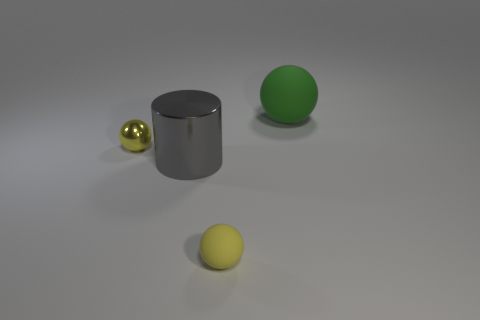Are there any other things that are the same material as the big gray object?
Give a very brief answer. Yes. What number of things are objects that are in front of the gray metallic thing or large objects?
Your response must be concise. 3. Is there a green matte sphere left of the big object in front of the big green rubber thing that is behind the cylinder?
Give a very brief answer. No. How many cyan cylinders are there?
Offer a terse response. 0. How many things are spheres on the right side of the large gray object or metallic objects behind the large gray object?
Offer a very short reply. 3. Is the size of the yellow sphere to the right of the gray object the same as the large green sphere?
Make the answer very short. No. There is a yellow matte thing that is the same shape as the big green object; what is its size?
Make the answer very short. Small. There is a ball that is the same size as the gray thing; what is it made of?
Provide a succinct answer. Rubber. What is the material of the other tiny thing that is the same shape as the yellow matte object?
Your answer should be compact. Metal. What number of other things are there of the same size as the gray shiny thing?
Your response must be concise. 1. 